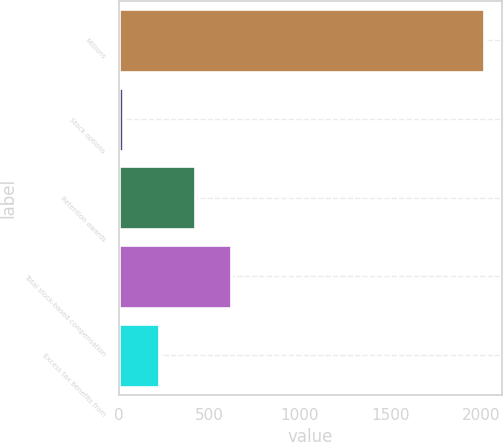Convert chart. <chart><loc_0><loc_0><loc_500><loc_500><bar_chart><fcel>Millions<fcel>Stock options<fcel>Retention awards<fcel>Total stock-based compensation<fcel>Excess tax benefits from<nl><fcel>2017<fcel>19<fcel>418.6<fcel>618.4<fcel>218.8<nl></chart> 